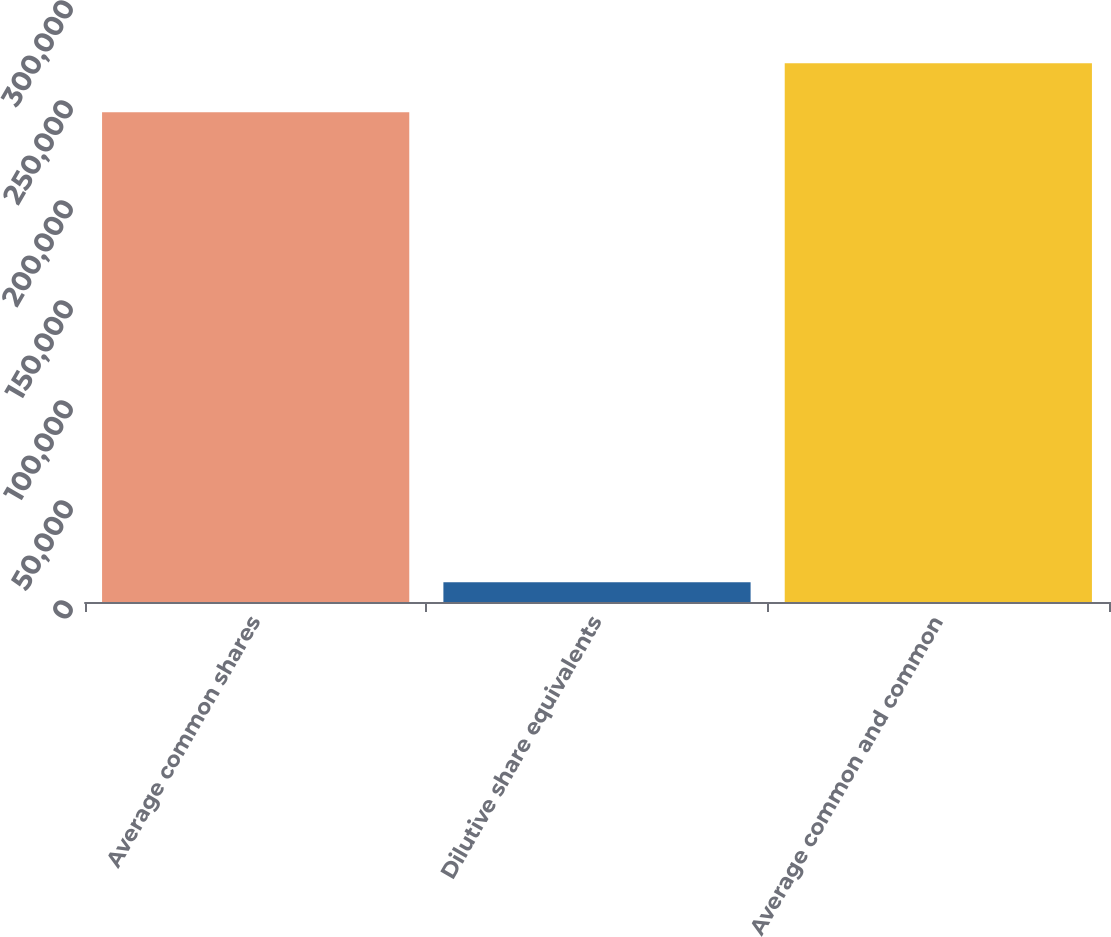Convert chart to OTSL. <chart><loc_0><loc_0><loc_500><loc_500><bar_chart><fcel>Average common shares<fcel>Dilutive share equivalents<fcel>Average common and common<nl><fcel>244929<fcel>9881<fcel>269422<nl></chart> 